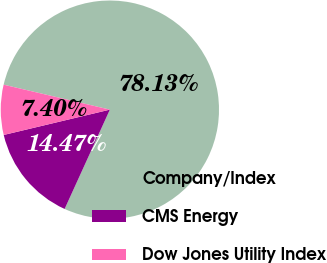Convert chart. <chart><loc_0><loc_0><loc_500><loc_500><pie_chart><fcel>Company/Index<fcel>CMS Energy<fcel>Dow Jones Utility Index<nl><fcel>78.13%<fcel>14.47%<fcel>7.4%<nl></chart> 